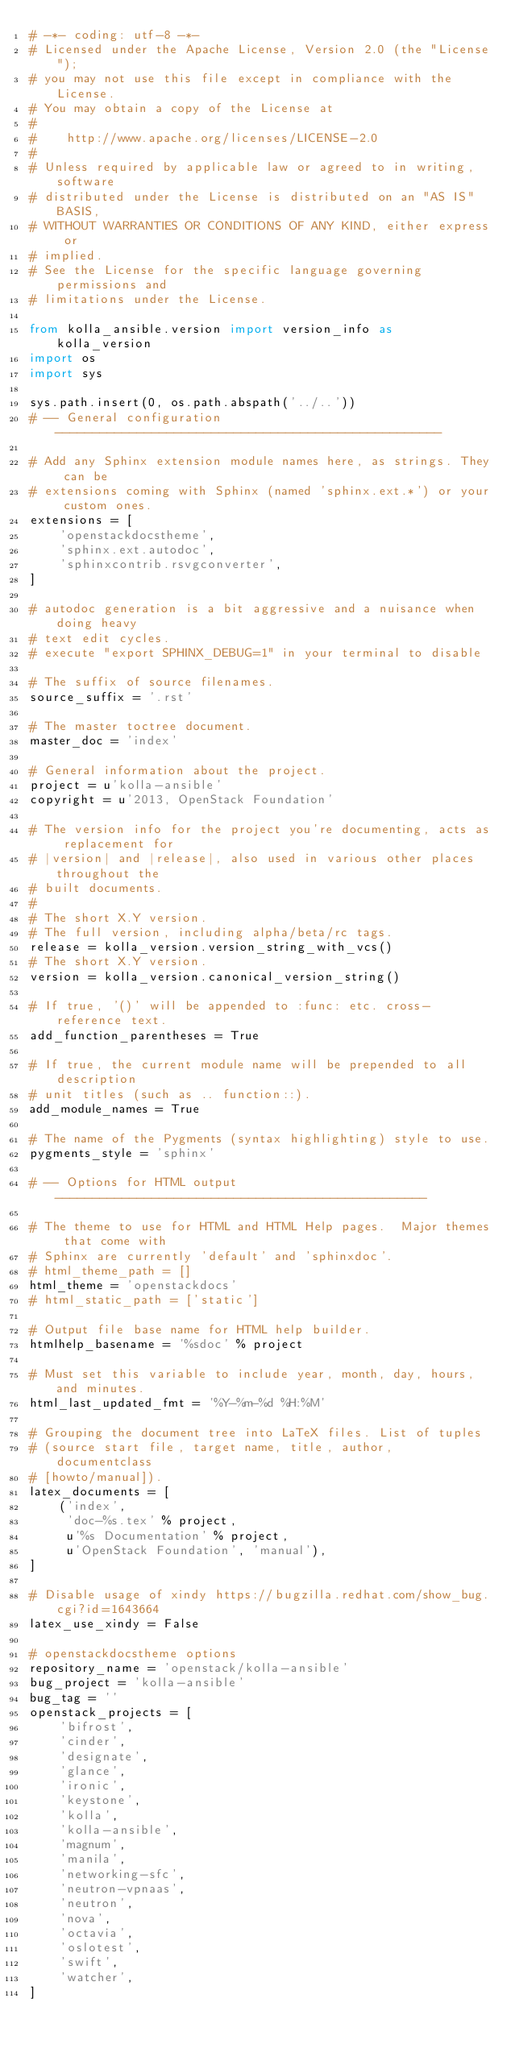Convert code to text. <code><loc_0><loc_0><loc_500><loc_500><_Python_># -*- coding: utf-8 -*-
# Licensed under the Apache License, Version 2.0 (the "License");
# you may not use this file except in compliance with the License.
# You may obtain a copy of the License at
#
#    http://www.apache.org/licenses/LICENSE-2.0
#
# Unless required by applicable law or agreed to in writing, software
# distributed under the License is distributed on an "AS IS" BASIS,
# WITHOUT WARRANTIES OR CONDITIONS OF ANY KIND, either express or
# implied.
# See the License for the specific language governing permissions and
# limitations under the License.

from kolla_ansible.version import version_info as kolla_version
import os
import sys

sys.path.insert(0, os.path.abspath('../..'))
# -- General configuration ----------------------------------------------------

# Add any Sphinx extension module names here, as strings. They can be
# extensions coming with Sphinx (named 'sphinx.ext.*') or your custom ones.
extensions = [
    'openstackdocstheme',
    'sphinx.ext.autodoc',
    'sphinxcontrib.rsvgconverter',
]

# autodoc generation is a bit aggressive and a nuisance when doing heavy
# text edit cycles.
# execute "export SPHINX_DEBUG=1" in your terminal to disable

# The suffix of source filenames.
source_suffix = '.rst'

# The master toctree document.
master_doc = 'index'

# General information about the project.
project = u'kolla-ansible'
copyright = u'2013, OpenStack Foundation'

# The version info for the project you're documenting, acts as replacement for
# |version| and |release|, also used in various other places throughout the
# built documents.
#
# The short X.Y version.
# The full version, including alpha/beta/rc tags.
release = kolla_version.version_string_with_vcs()
# The short X.Y version.
version = kolla_version.canonical_version_string()

# If true, '()' will be appended to :func: etc. cross-reference text.
add_function_parentheses = True

# If true, the current module name will be prepended to all description
# unit titles (such as .. function::).
add_module_names = True

# The name of the Pygments (syntax highlighting) style to use.
pygments_style = 'sphinx'

# -- Options for HTML output --------------------------------------------------

# The theme to use for HTML and HTML Help pages.  Major themes that come with
# Sphinx are currently 'default' and 'sphinxdoc'.
# html_theme_path = []
html_theme = 'openstackdocs'
# html_static_path = ['static']

# Output file base name for HTML help builder.
htmlhelp_basename = '%sdoc' % project

# Must set this variable to include year, month, day, hours, and minutes.
html_last_updated_fmt = '%Y-%m-%d %H:%M'

# Grouping the document tree into LaTeX files. List of tuples
# (source start file, target name, title, author, documentclass
# [howto/manual]).
latex_documents = [
    ('index',
     'doc-%s.tex' % project,
     u'%s Documentation' % project,
     u'OpenStack Foundation', 'manual'),
]

# Disable usage of xindy https://bugzilla.redhat.com/show_bug.cgi?id=1643664
latex_use_xindy = False

# openstackdocstheme options
repository_name = 'openstack/kolla-ansible'
bug_project = 'kolla-ansible'
bug_tag = ''
openstack_projects = [
    'bifrost',
    'cinder',
    'designate',
    'glance',
    'ironic',
    'keystone',
    'kolla',
    'kolla-ansible',
    'magnum',
    'manila',
    'networking-sfc',
    'neutron-vpnaas',
    'neutron',
    'nova',
    'octavia',
    'oslotest',
    'swift',
    'watcher',
]
</code> 